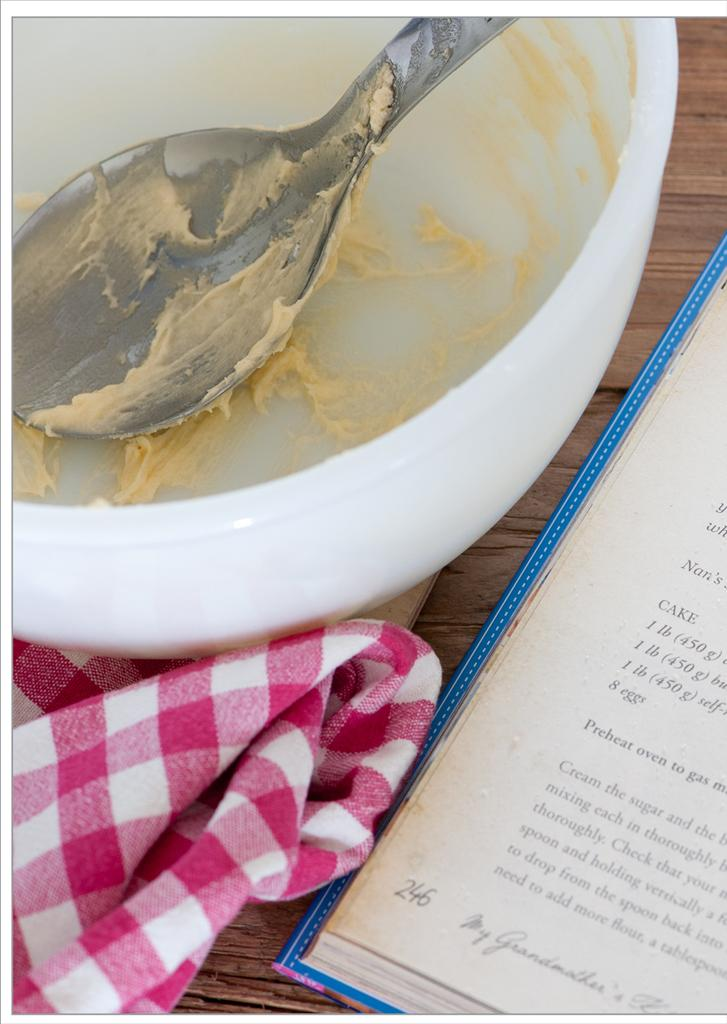What is in the bowl that is visible in the image? There is a bowl in the image, but the contents are not specified. What utensil is visible in the image? There is a spoon in the image. What is on the spoon in the image? The spoon has some batter on it. What item can be used for drying hands in the image? There is a hand towel in the image. What object is on the table in the image? There is a book on the table in the image. What is the tendency of the book to make a discovery in the scene? There is no indication of the book making a discovery or having a tendency to do so in the image. 